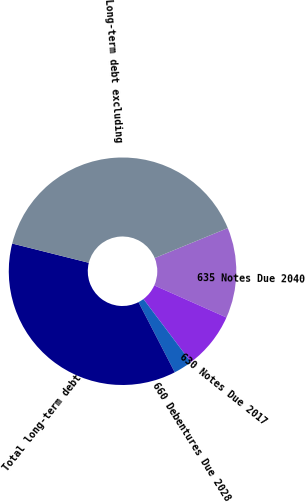Convert chart. <chart><loc_0><loc_0><loc_500><loc_500><pie_chart><fcel>635 Notes Due 2040<fcel>630 Notes Due 2017<fcel>660 Debentures Due 2028<fcel>Total long-term debt<fcel>Long-term debt excluding<nl><fcel>12.86%<fcel>8.07%<fcel>2.68%<fcel>36.51%<fcel>39.89%<nl></chart> 